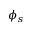Convert formula to latex. <formula><loc_0><loc_0><loc_500><loc_500>\phi _ { s }</formula> 